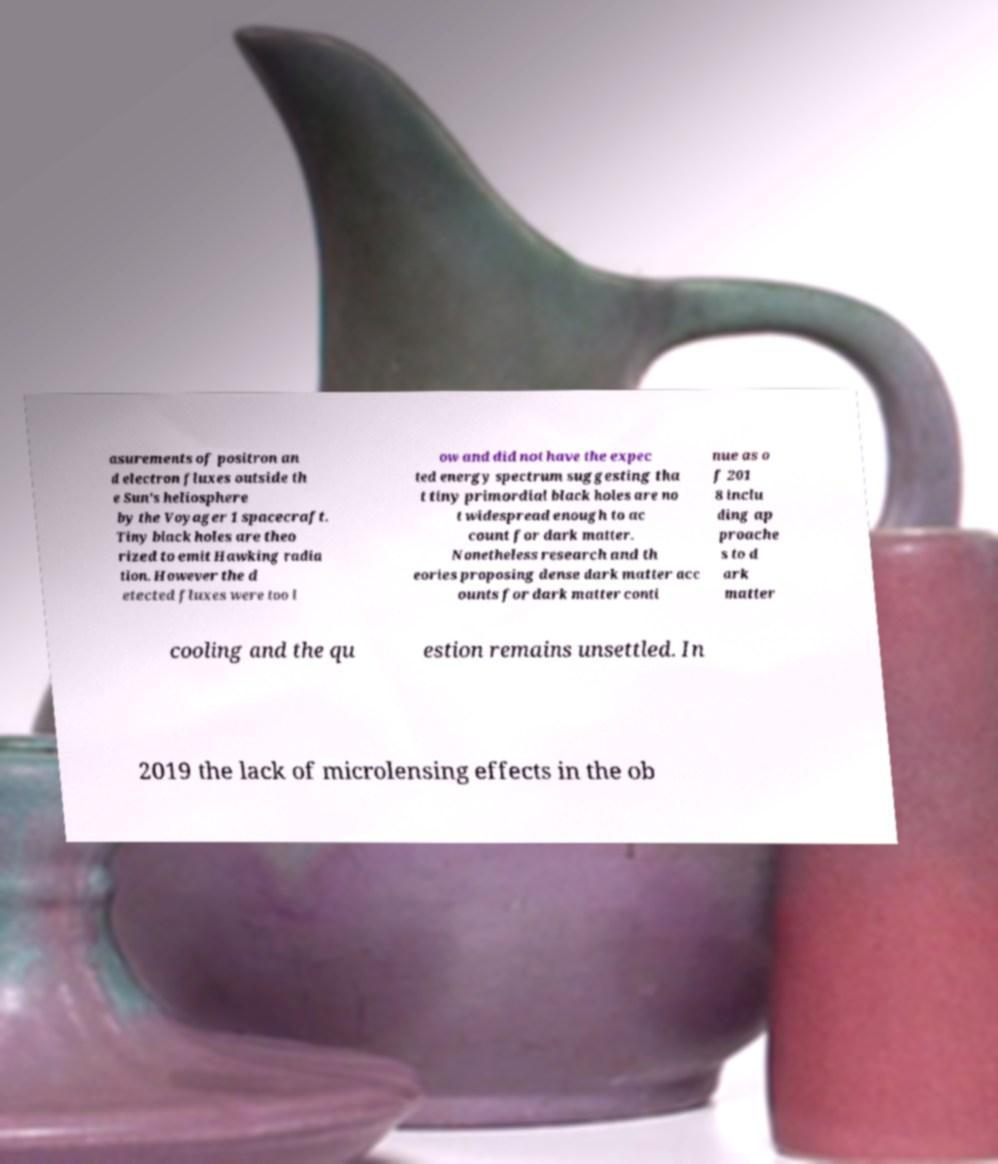What messages or text are displayed in this image? I need them in a readable, typed format. asurements of positron an d electron fluxes outside th e Sun's heliosphere by the Voyager 1 spacecraft. Tiny black holes are theo rized to emit Hawking radia tion. However the d etected fluxes were too l ow and did not have the expec ted energy spectrum suggesting tha t tiny primordial black holes are no t widespread enough to ac count for dark matter. Nonetheless research and th eories proposing dense dark matter acc ounts for dark matter conti nue as o f 201 8 inclu ding ap proache s to d ark matter cooling and the qu estion remains unsettled. In 2019 the lack of microlensing effects in the ob 